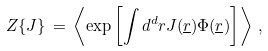<formula> <loc_0><loc_0><loc_500><loc_500>Z \{ J \} \, = \, \left \langle \exp \left [ \int d ^ { d } r J ( \underline { r } ) \Phi ( \underline { r } ) \right ] \right \rangle \, ,</formula> 